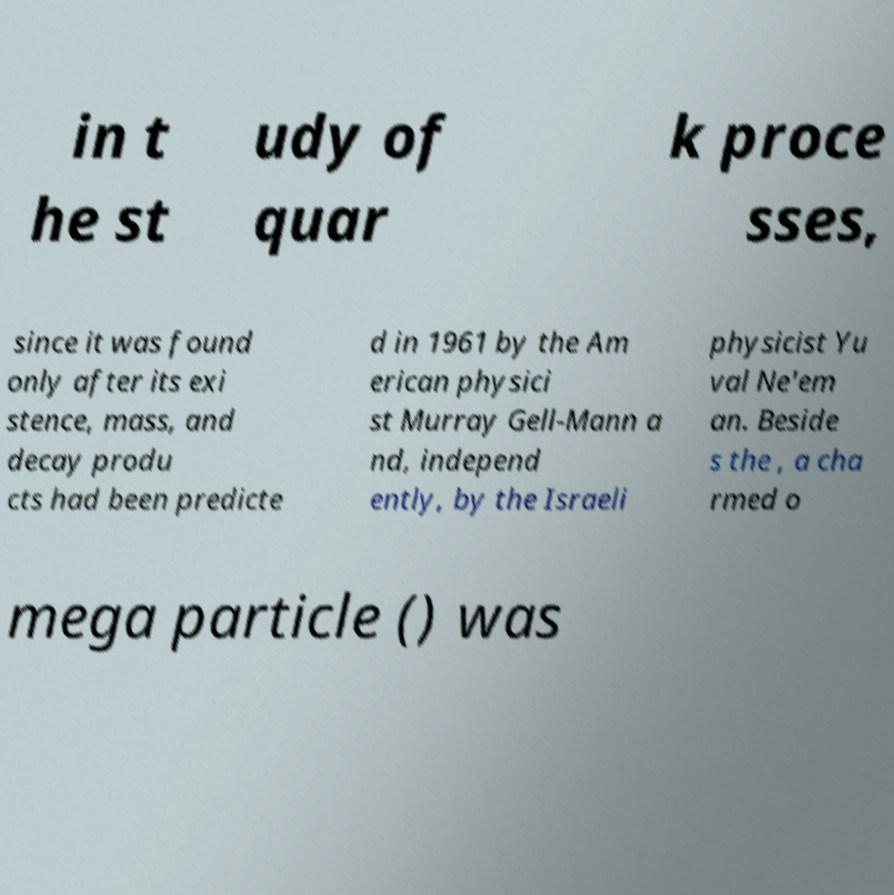There's text embedded in this image that I need extracted. Can you transcribe it verbatim? in t he st udy of quar k proce sses, since it was found only after its exi stence, mass, and decay produ cts had been predicte d in 1961 by the Am erican physici st Murray Gell-Mann a nd, independ ently, by the Israeli physicist Yu val Ne'em an. Beside s the , a cha rmed o mega particle () was 